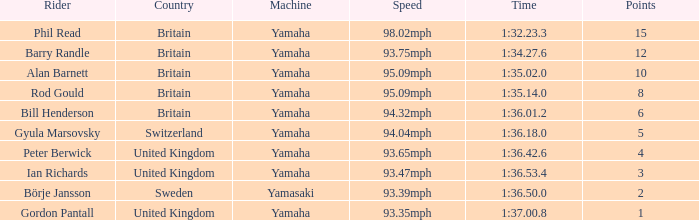For the person who earned 1 point, what was their time? 1:37.00.8. 